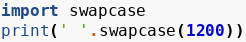Convert code to text. <code><loc_0><loc_0><loc_500><loc_500><_Python_>import swapcase
print(' '.swapcase(1200))</code> 